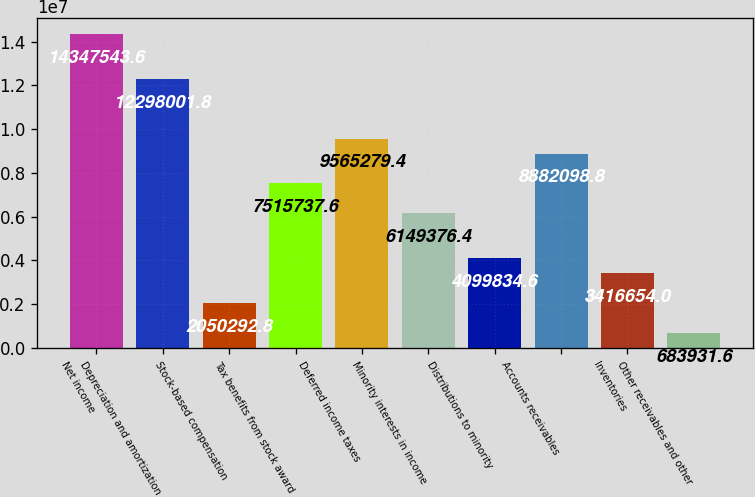Convert chart. <chart><loc_0><loc_0><loc_500><loc_500><bar_chart><fcel>Net income<fcel>Depreciation and amortization<fcel>Stock-based compensation<fcel>Tax benefits from stock award<fcel>Deferred income taxes<fcel>Minority interests in income<fcel>Distributions to minority<fcel>Accounts receivables<fcel>Inventories<fcel>Other receivables and other<nl><fcel>1.43475e+07<fcel>1.2298e+07<fcel>2.05029e+06<fcel>7.51574e+06<fcel>9.56528e+06<fcel>6.14938e+06<fcel>4.09983e+06<fcel>8.8821e+06<fcel>3.41665e+06<fcel>683932<nl></chart> 